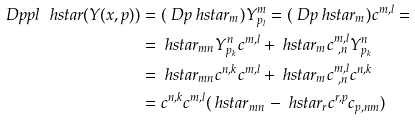<formula> <loc_0><loc_0><loc_500><loc_500>\ D p p { l } \ h s t a r ( Y ( x , p ) ) & = ( \ D p \ h s t a r _ { m } ) Y ^ { m } _ { p _ { l } } = ( \ D p \ h s t a r _ { m } ) c ^ { m , l } = \\ & = \ h s t a r _ { m n } Y ^ { n } _ { p _ { k } } c ^ { m , l } + \ h s t a r _ { m } c ^ { m , l } _ { \ , n } Y ^ { n } _ { p _ { k } } \\ & = \ h s t a r _ { m n } c ^ { n , k } c ^ { m , l } + \ h s t a r _ { m } c ^ { m , l } _ { \ , n } c ^ { n , k } \\ & = c ^ { n , k } c ^ { m , l } ( \ h s t a r _ { m n } - \ h s t a r _ { r } c ^ { r , p } c _ { p , n m } ) \\</formula> 